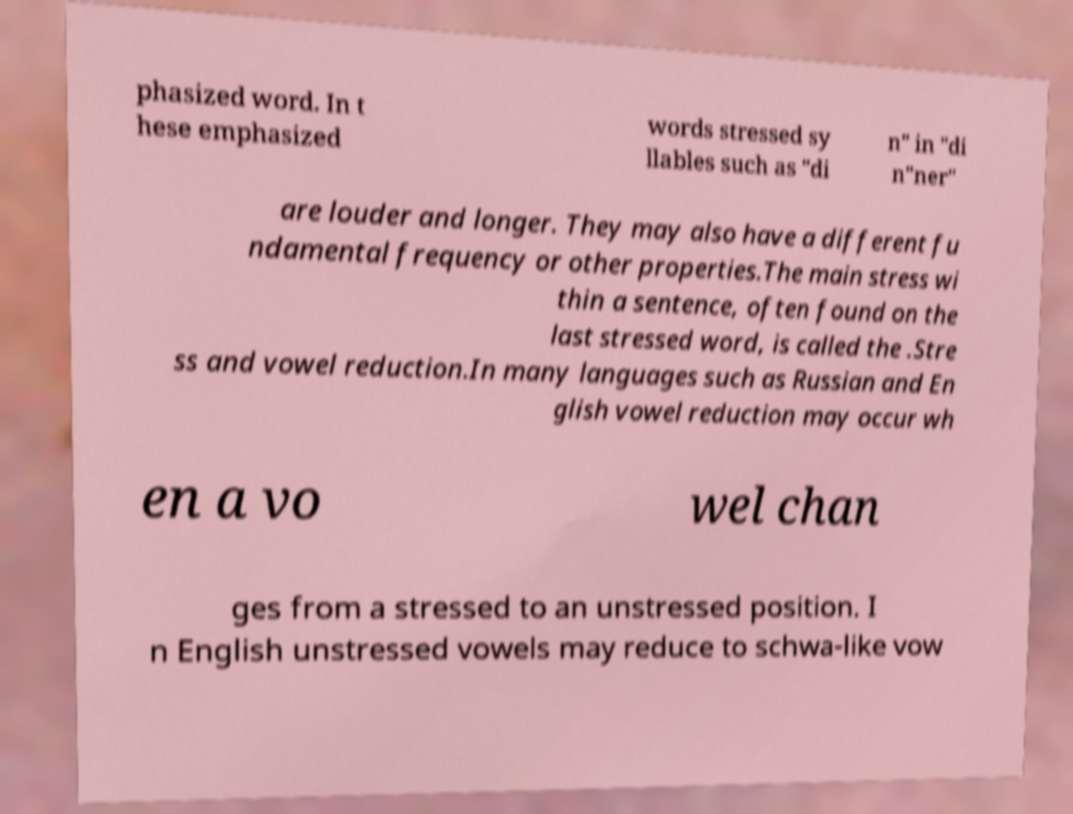Could you assist in decoding the text presented in this image and type it out clearly? phasized word. In t hese emphasized words stressed sy llables such as "di n" in "di n"ner" are louder and longer. They may also have a different fu ndamental frequency or other properties.The main stress wi thin a sentence, often found on the last stressed word, is called the .Stre ss and vowel reduction.In many languages such as Russian and En glish vowel reduction may occur wh en a vo wel chan ges from a stressed to an unstressed position. I n English unstressed vowels may reduce to schwa-like vow 